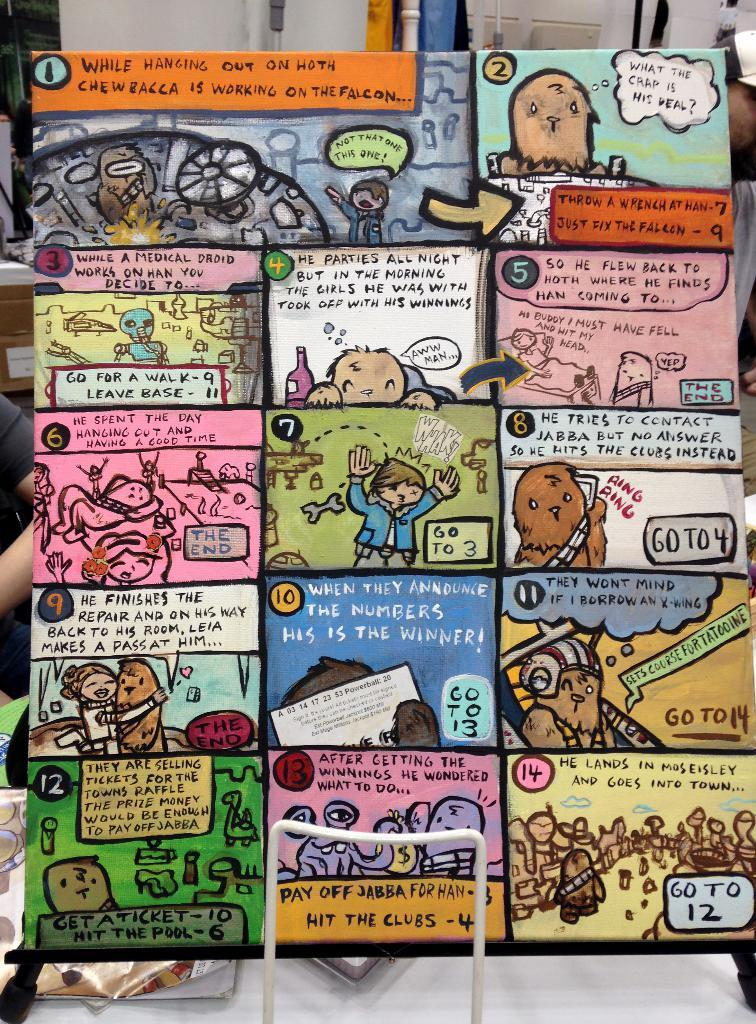What is the main object in the image? There is a board in the image. What is on the board? There are painted papers on the board. Can you describe any other elements in the image? There is a person's hand visible behind the board. What type of river is flowing behind the board in the image? There is no river present in the image; it only features a board with painted papers and a person's hand. 